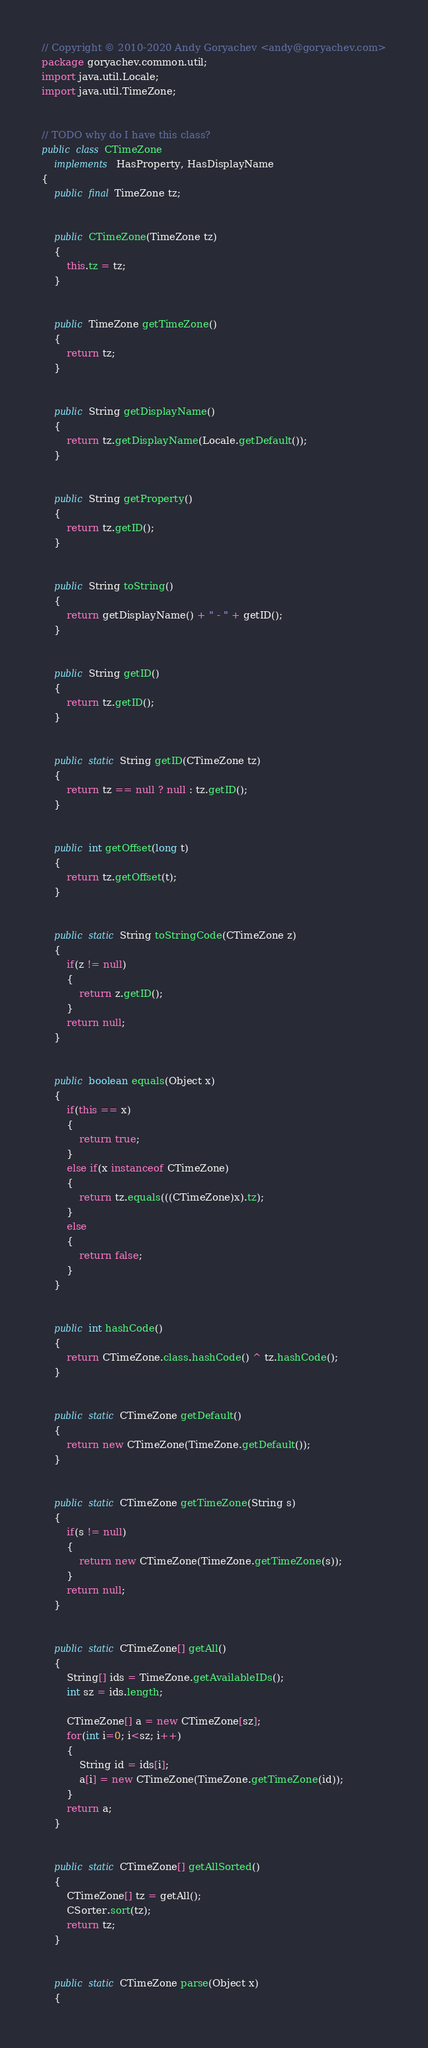Convert code to text. <code><loc_0><loc_0><loc_500><loc_500><_Java_>// Copyright © 2010-2020 Andy Goryachev <andy@goryachev.com>
package goryachev.common.util;
import java.util.Locale;
import java.util.TimeZone;


// TODO why do I have this class?
public class CTimeZone
	implements HasProperty, HasDisplayName
{
	public final TimeZone tz;


	public CTimeZone(TimeZone tz)
	{
		this.tz = tz;
	}
	
	
	public TimeZone getTimeZone()
	{
		return tz;
	}


	public String getDisplayName()
	{
		return tz.getDisplayName(Locale.getDefault());
	}


	public String getProperty()
	{
		return tz.getID();
	}
	
	
	public String toString()
	{
		return getDisplayName() + " - " + getID();
	}
	
	
	public String getID()
	{
		return tz.getID();
	}
	
	
	public static String getID(CTimeZone tz)
	{
		return tz == null ? null : tz.getID();
	}
	
	
	public int getOffset(long t)
	{
		return tz.getOffset(t);
	}
	
	
	public static String toStringCode(CTimeZone z)
	{
		if(z != null)
		{
			return z.getID();
		}
		return null;
	}
	
	
	public boolean equals(Object x)
	{
		if(this == x)
		{
			return true;
		}
		else if(x instanceof CTimeZone)
		{
			return tz.equals(((CTimeZone)x).tz);
		}
		else
		{
			return false;
		}
	}
	
	
	public int hashCode()
	{
		return CTimeZone.class.hashCode() ^ tz.hashCode();
	}
	
	
	public static CTimeZone getDefault()
	{
		return new CTimeZone(TimeZone.getDefault());
	}
	
	
	public static CTimeZone getTimeZone(String s)
	{
		if(s != null)
		{
			return new CTimeZone(TimeZone.getTimeZone(s));
		}
		return null;
	}


	public static CTimeZone[] getAll()
	{
		String[] ids = TimeZone.getAvailableIDs();
		int sz = ids.length;

		CTimeZone[] a = new CTimeZone[sz];
		for(int i=0; i<sz; i++)
		{
			String id = ids[i];
			a[i] = new CTimeZone(TimeZone.getTimeZone(id));
		}
		return a;
	}


	public static CTimeZone[] getAllSorted()
	{
		CTimeZone[] tz = getAll();
		CSorter.sort(tz);
		return tz;
	}
	
	
	public static CTimeZone parse(Object x)
	{</code> 